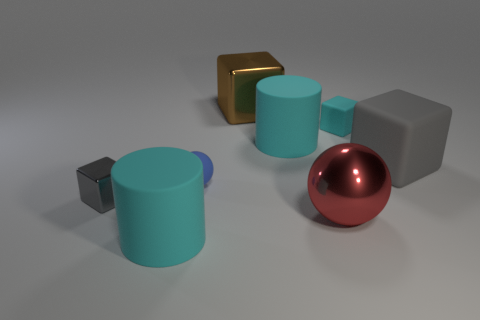Subtract all green spheres. How many gray blocks are left? 2 Subtract all brown cubes. How many cubes are left? 3 Subtract all brown metal blocks. How many blocks are left? 3 Add 1 large blue cubes. How many objects exist? 9 Subtract all blue cubes. Subtract all yellow cylinders. How many cubes are left? 4 Subtract all balls. How many objects are left? 6 Add 8 blue spheres. How many blue spheres exist? 9 Subtract 0 gray balls. How many objects are left? 8 Subtract all cyan rubber cylinders. Subtract all brown blocks. How many objects are left? 5 Add 5 brown cubes. How many brown cubes are left? 6 